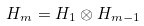Convert formula to latex. <formula><loc_0><loc_0><loc_500><loc_500>H _ { m } = H _ { 1 } \otimes H _ { m - 1 }</formula> 